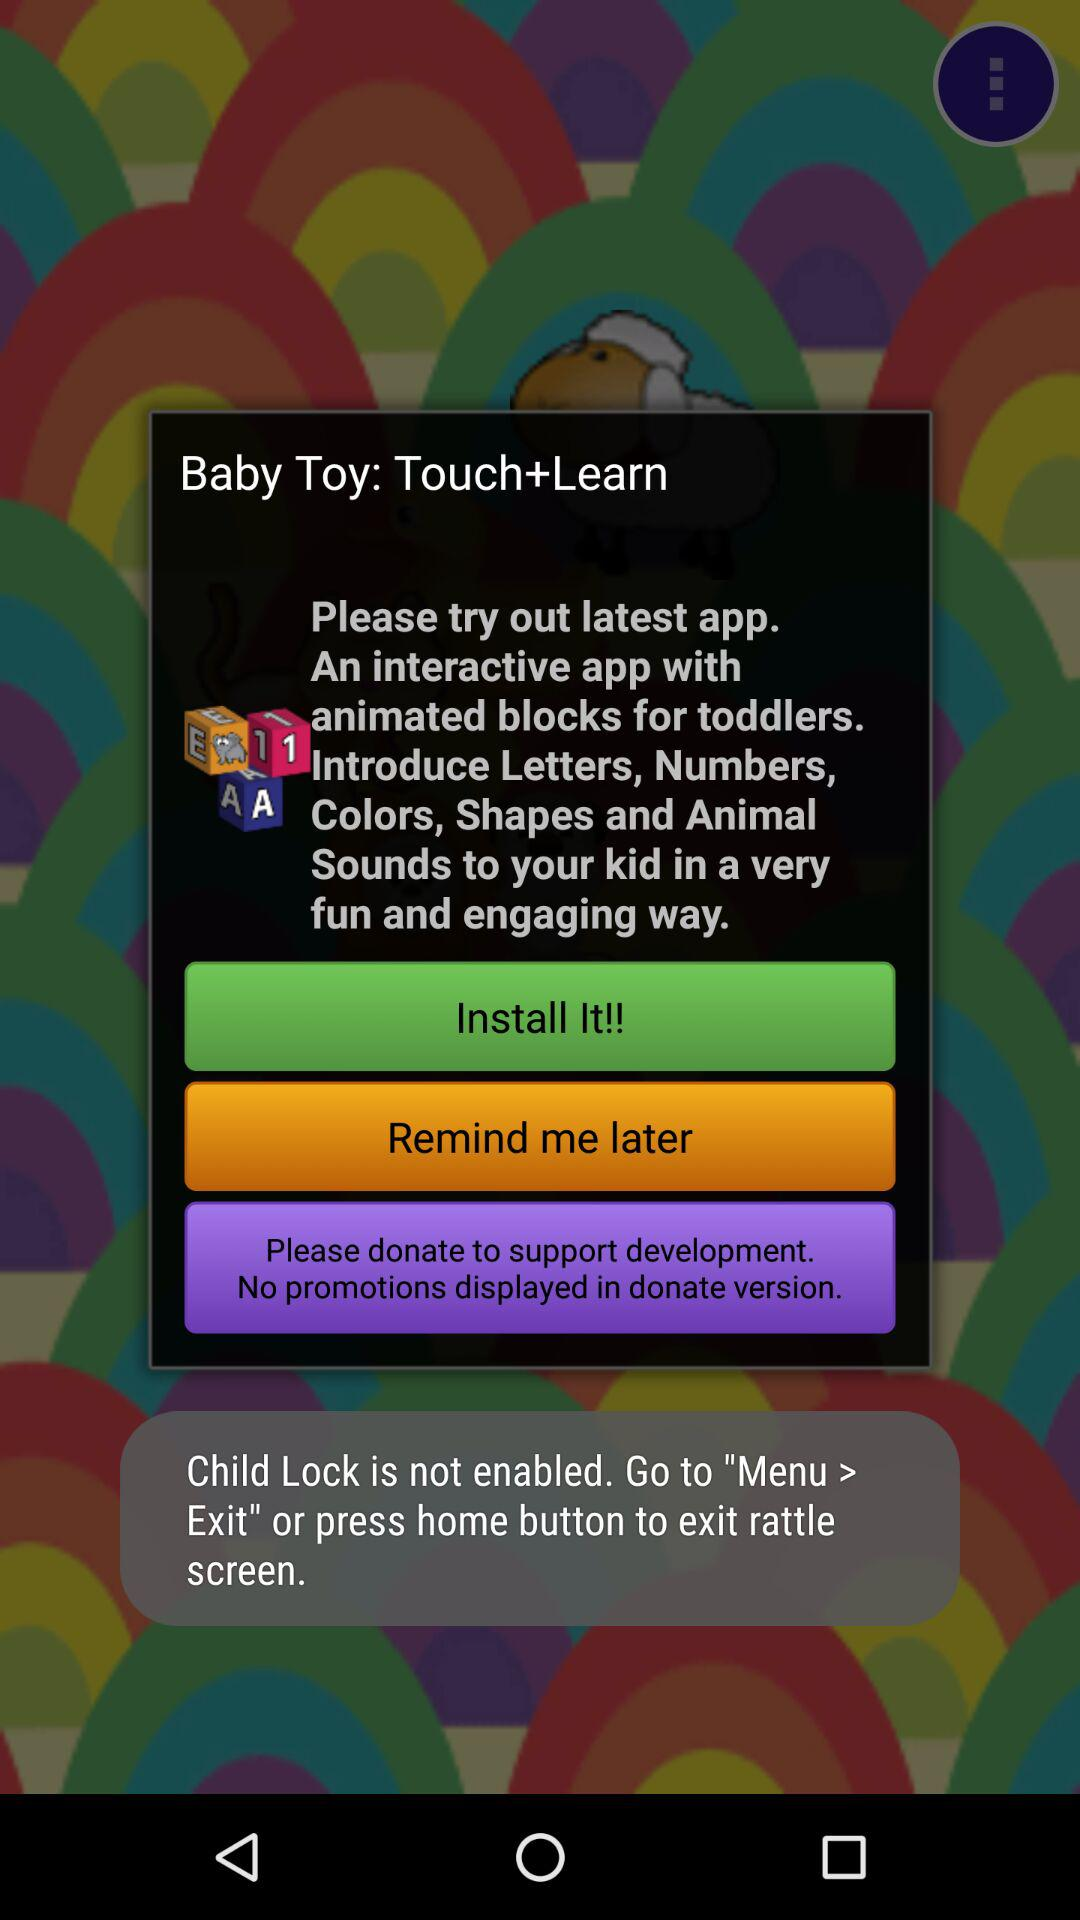What is this app about?
When the provided information is insufficient, respond with <no answer>. <no answer> 